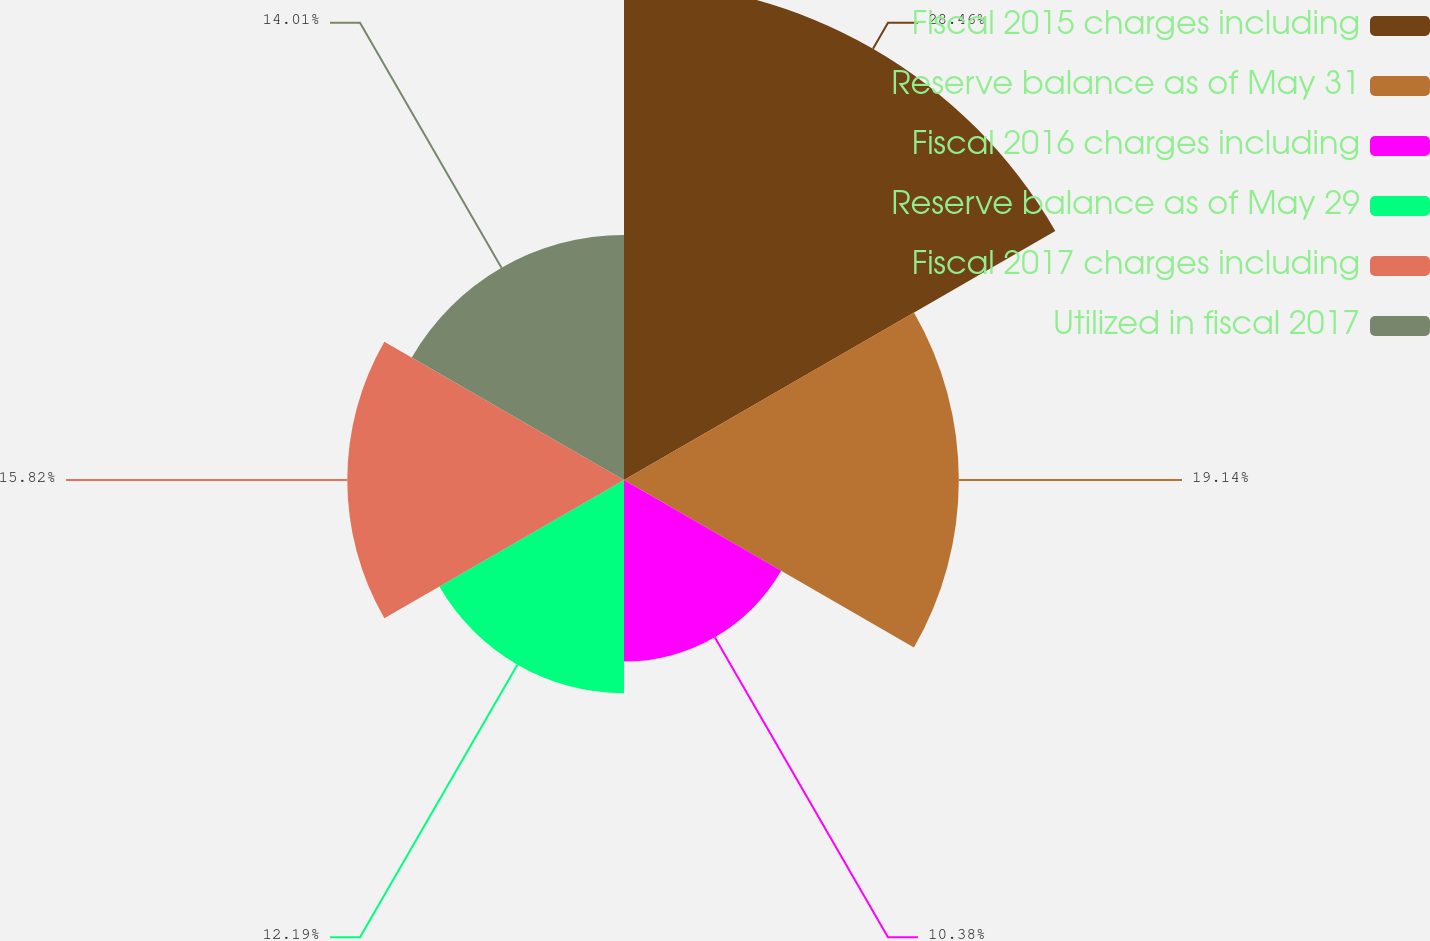Convert chart to OTSL. <chart><loc_0><loc_0><loc_500><loc_500><pie_chart><fcel>Fiscal 2015 charges including<fcel>Reserve balance as of May 31<fcel>Fiscal 2016 charges including<fcel>Reserve balance as of May 29<fcel>Fiscal 2017 charges including<fcel>Utilized in fiscal 2017<nl><fcel>28.47%<fcel>19.14%<fcel>10.38%<fcel>12.19%<fcel>15.82%<fcel>14.01%<nl></chart> 